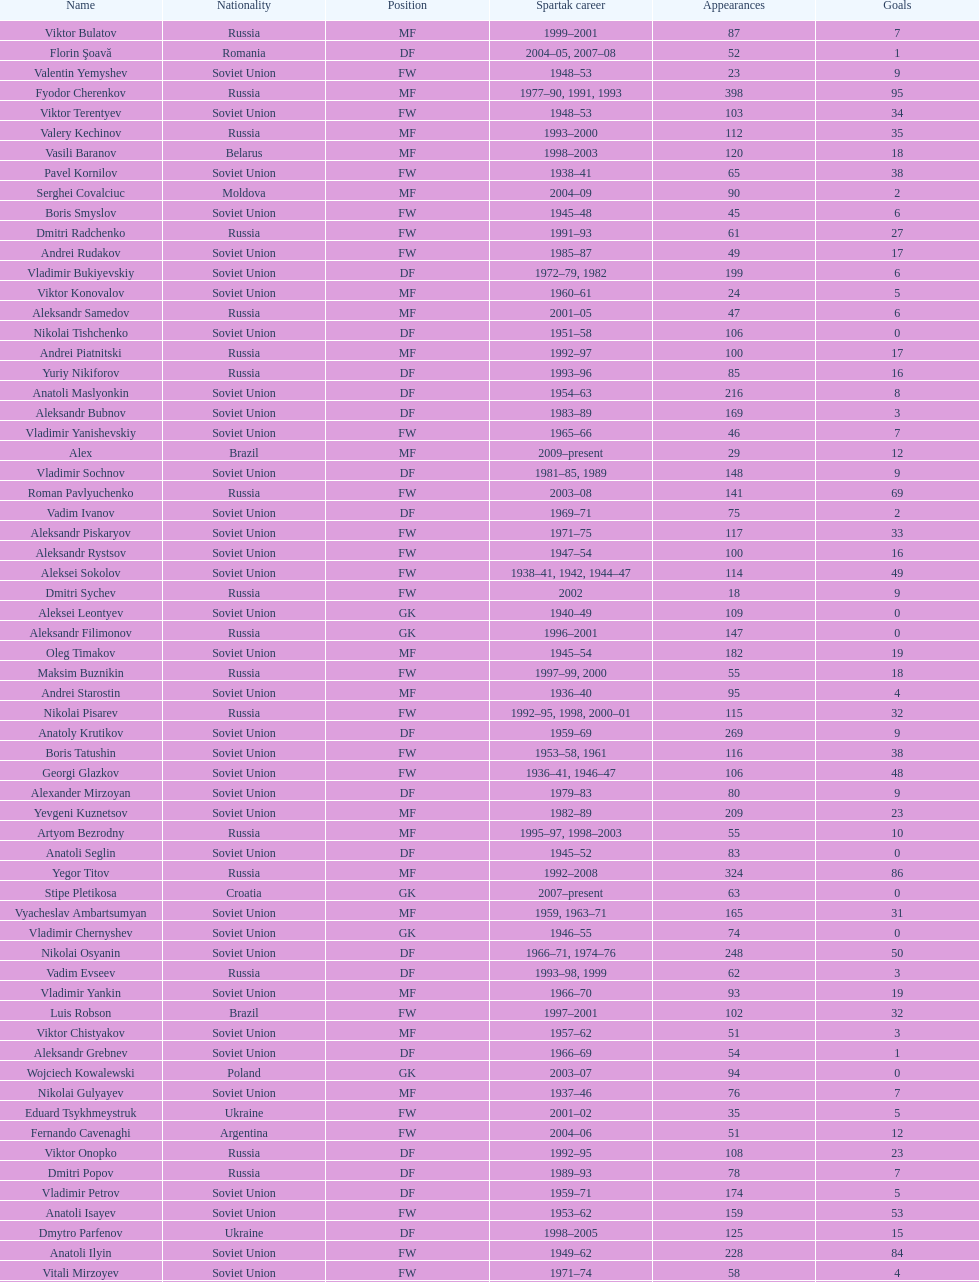Vladimir bukiyevskiy had how many appearances? 199. 